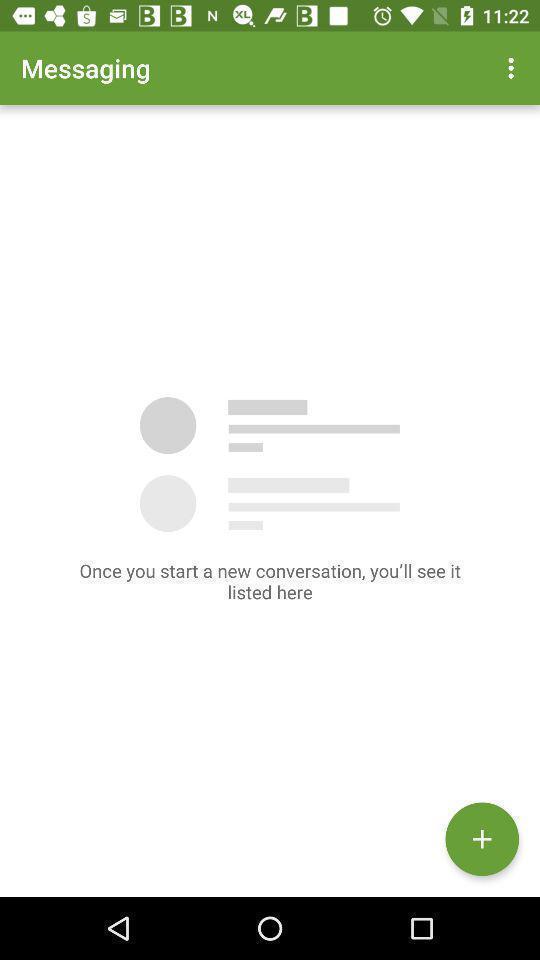Explain the elements present in this screenshot. Screen showing blank page of messages. 